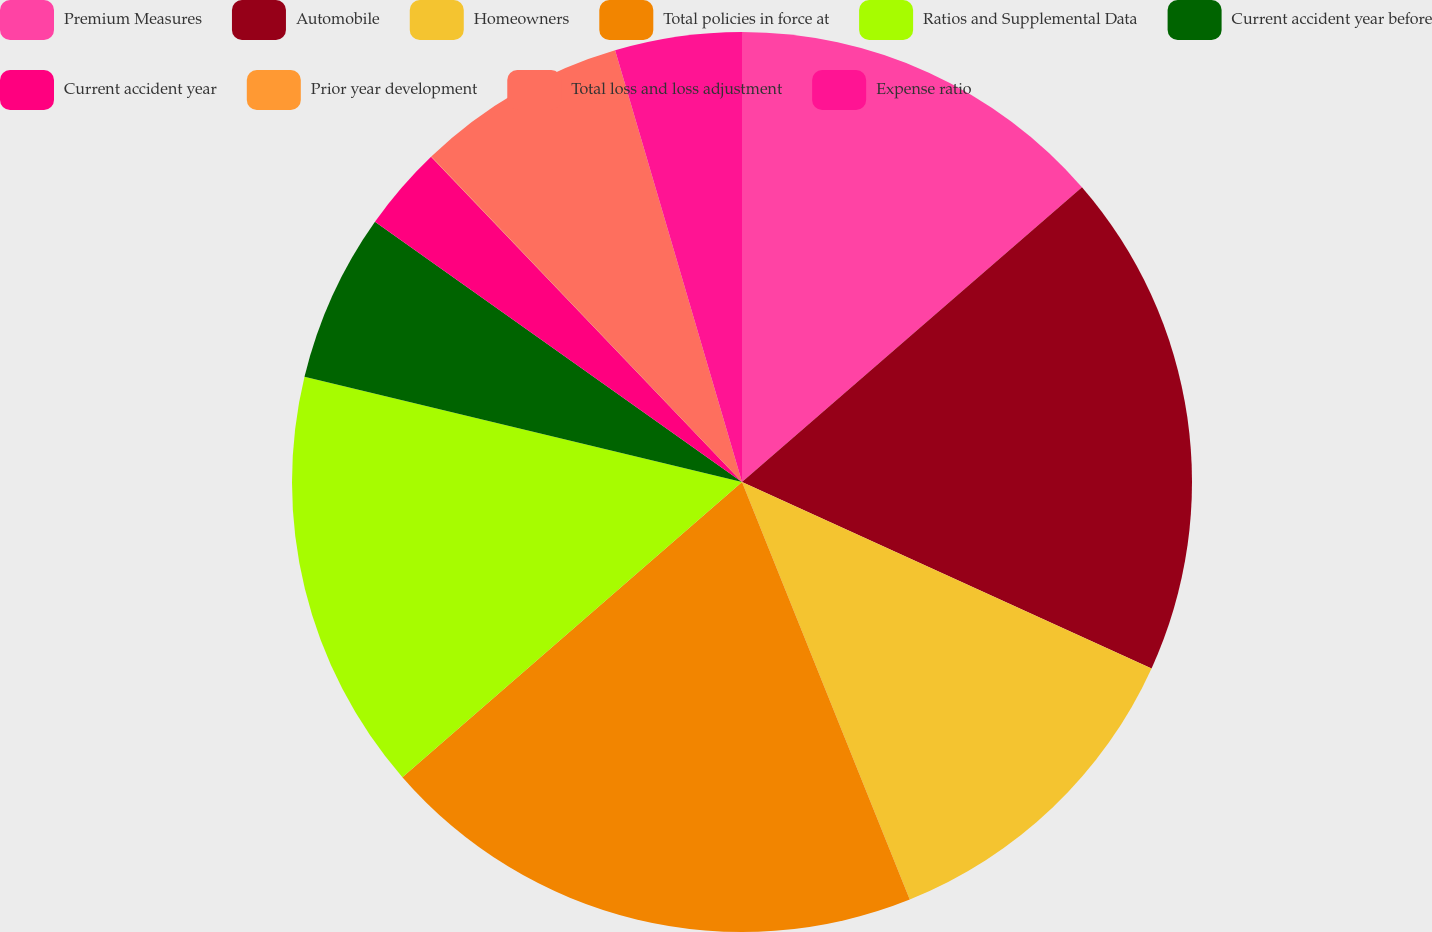<chart> <loc_0><loc_0><loc_500><loc_500><pie_chart><fcel>Premium Measures<fcel>Automobile<fcel>Homeowners<fcel>Total policies in force at<fcel>Ratios and Supplemental Data<fcel>Current accident year before<fcel>Current accident year<fcel>Prior year development<fcel>Total loss and loss adjustment<fcel>Expense ratio<nl><fcel>13.63%<fcel>18.17%<fcel>12.12%<fcel>19.69%<fcel>15.15%<fcel>6.06%<fcel>3.04%<fcel>0.01%<fcel>7.58%<fcel>4.55%<nl></chart> 